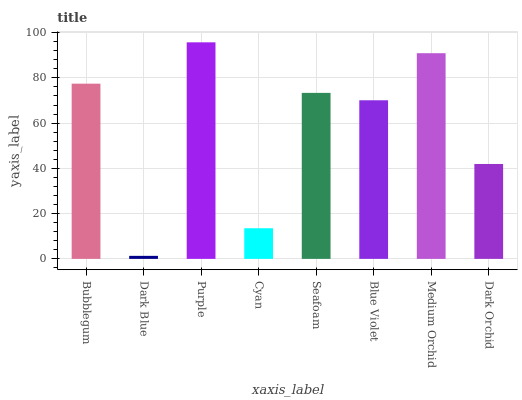Is Dark Blue the minimum?
Answer yes or no. Yes. Is Purple the maximum?
Answer yes or no. Yes. Is Purple the minimum?
Answer yes or no. No. Is Dark Blue the maximum?
Answer yes or no. No. Is Purple greater than Dark Blue?
Answer yes or no. Yes. Is Dark Blue less than Purple?
Answer yes or no. Yes. Is Dark Blue greater than Purple?
Answer yes or no. No. Is Purple less than Dark Blue?
Answer yes or no. No. Is Seafoam the high median?
Answer yes or no. Yes. Is Blue Violet the low median?
Answer yes or no. Yes. Is Blue Violet the high median?
Answer yes or no. No. Is Purple the low median?
Answer yes or no. No. 